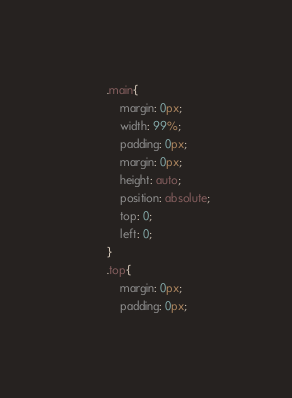Convert code to text. <code><loc_0><loc_0><loc_500><loc_500><_CSS_>		.main{
			margin: 0px;
			width: 99%;
			padding: 0px;
			margin: 0px;
			height: auto;
			position: absolute;
			top: 0;
			left: 0;
		}
		.top{
			margin: 0px;
			padding: 0px;</code> 